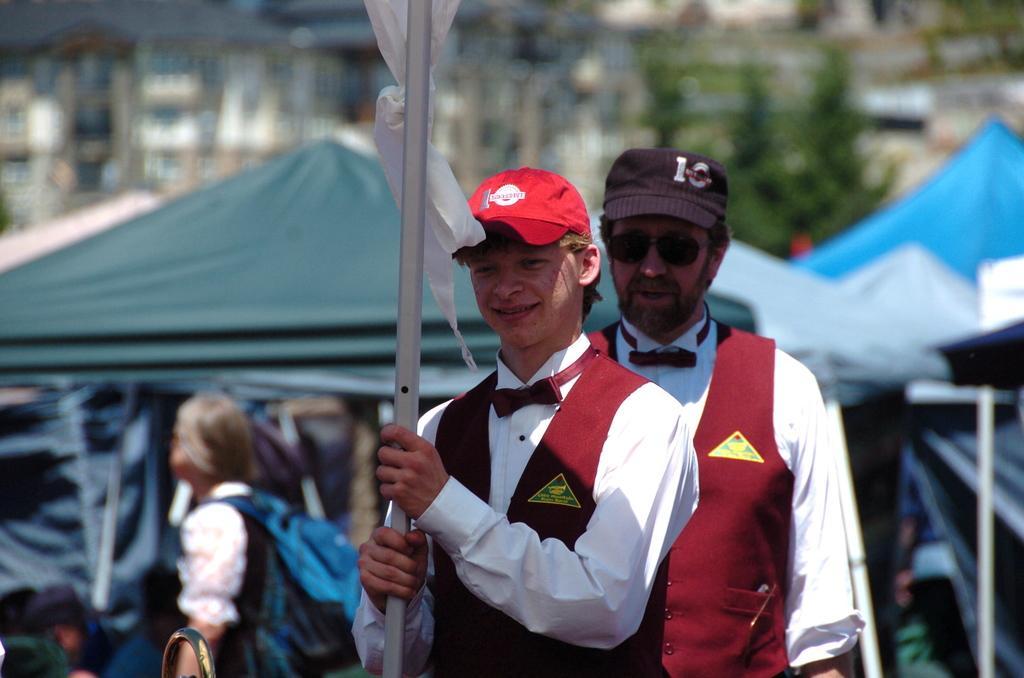Describe this image in one or two sentences. In the center of the image there is a boy holding a pole in his hand. He is wearing a red color cap. Behind him there is another person he is wearing a black color cap. In the background of the image there are tents,trees,buildings. There are people. 